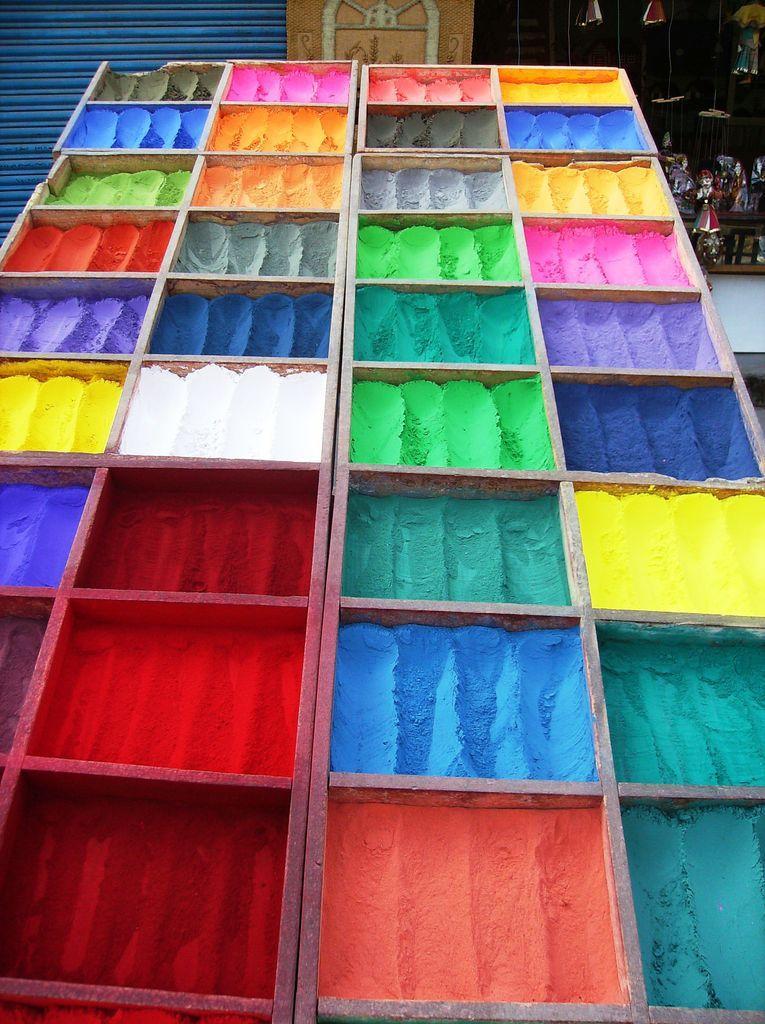In one or two sentences, can you explain what this image depicts? In this picture we can see wooden boxes, there are some colors in these boxes, in the background there is a shutter. 